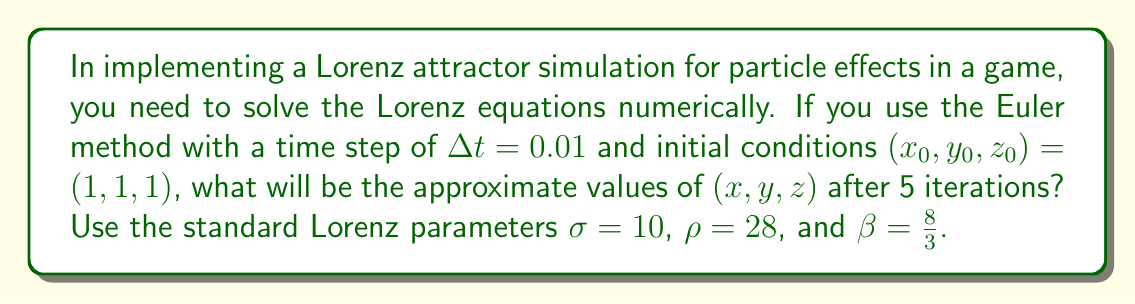Teach me how to tackle this problem. To solve this problem, we'll use the Euler method to numerically integrate the Lorenz equations:

$$\frac{dx}{dt} = \sigma(y - x)$$
$$\frac{dy}{dt} = x(\rho - z) - y$$
$$\frac{dz}{dt} = xy - \beta z$$

The Euler method for a system of ODEs is given by:

$$x_{n+1} = x_n + \Delta t \cdot f(x_n, y_n, z_n)$$
$$y_{n+1} = y_n + \Delta t \cdot g(x_n, y_n, z_n)$$
$$z_{n+1} = z_n + \Delta t \cdot h(x_n, y_n, z_n)$$

Where $f$, $g$, and $h$ are the right-hand sides of the Lorenz equations.

Let's calculate each iteration:

Iteration 1:
$x_1 = 1 + 0.01 \cdot 10(1 - 1) = 1$
$y_1 = 1 + 0.01 \cdot (1(28 - 1) - 1) = 1.26$
$z_1 = 1 + 0.01 \cdot (1 \cdot 1 - \frac{8}{3} \cdot 1) = 0.9733$

Iteration 2:
$x_2 = 1 + 0.01 \cdot 10(1.26 - 1) = 1.026$
$y_2 = 1.26 + 0.01 \cdot (1(28 - 0.9733) - 1.26) = 1.5273$
$z_2 = 0.9733 + 0.01 \cdot (1 \cdot 1.26 - \frac{8}{3} \cdot 0.9733) = 0.9742$

Iteration 3:
$x_3 = 1.026 + 0.01 \cdot 10(1.5273 - 1.026) = 1.0776$
$y_3 = 1.5273 + 0.01 \cdot (1.026(28 - 0.9742) - 1.5273) = 1.8145$
$z_3 = 0.9742 + 0.01 \cdot (1.026 \cdot 1.5273 - \frac{8}{3} \cdot 0.9742) = 0.9880$

Iteration 4:
$x_4 = 1.0776 + 0.01 \cdot 10(1.8145 - 1.0776) = 1.1514$
$y_4 = 1.8145 + 0.01 \cdot (1.0776(28 - 0.9880) - 1.8145) = 2.1211$
$z_4 = 0.9880 + 0.01 \cdot (1.0776 \cdot 1.8145 - \frac{8}{3} \cdot 0.9880) = 1.0179$

Iteration 5:
$x_5 = 1.1514 + 0.01 \cdot 10(2.1211 - 1.1514) = 1.2484$
$y_5 = 2.1211 + 0.01 \cdot (1.1514(28 - 1.0179) - 2.1211) = 2.4458$
$z_5 = 1.0179 + 0.01 \cdot (1.1514 \cdot 2.1211 - \frac{8}{3} \cdot 1.0179) = 1.0667$
Answer: $(1.2484, 2.4458, 1.0667)$ 